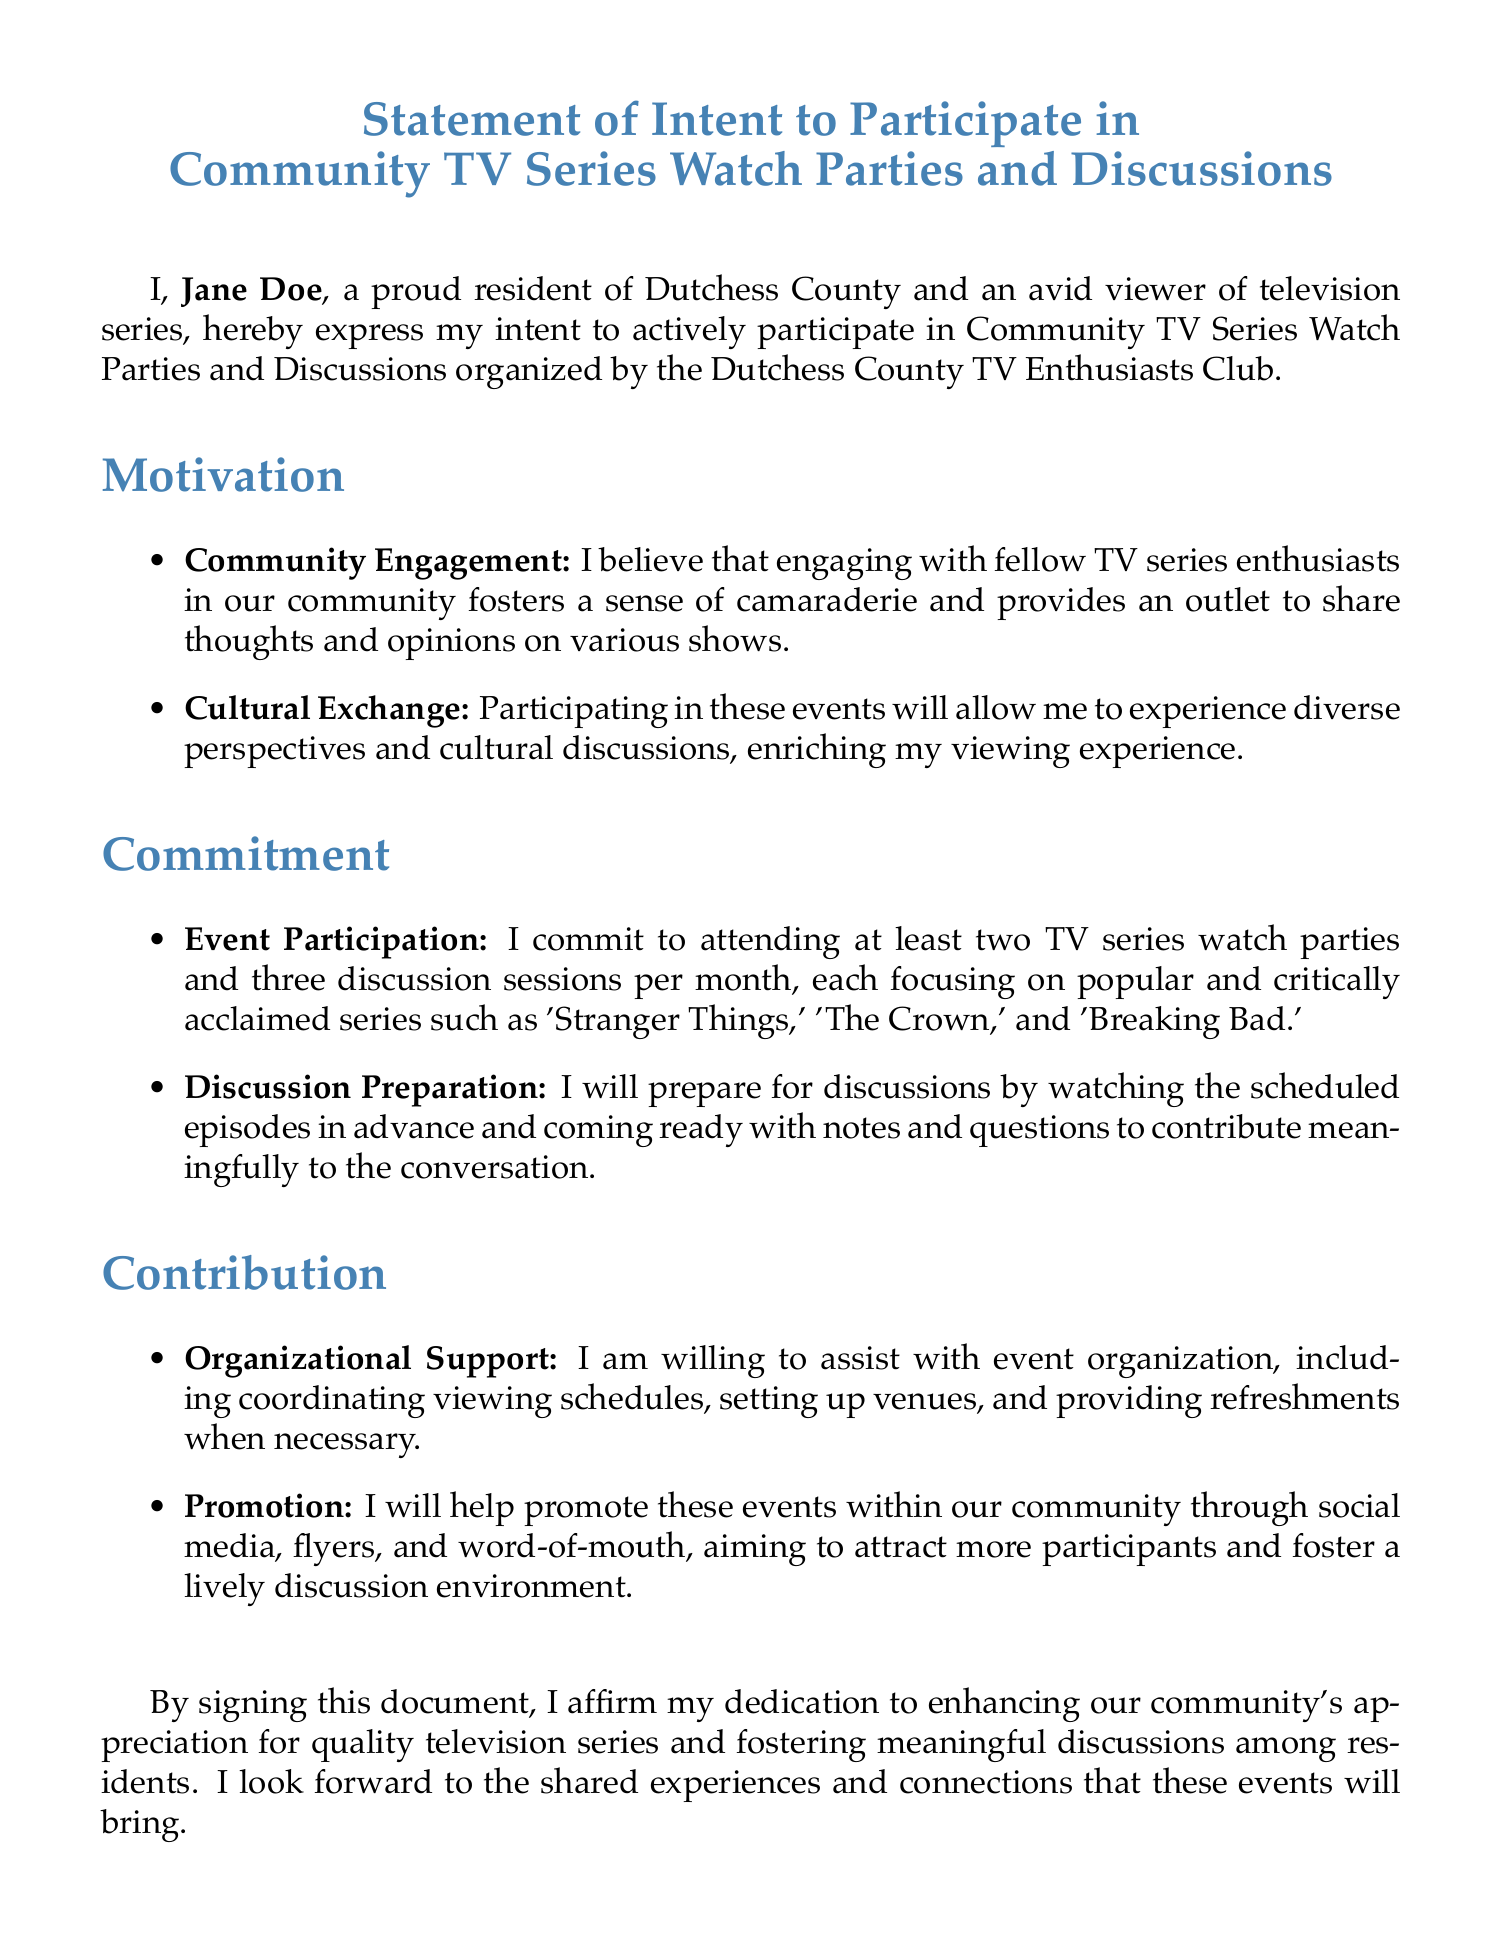What is the document titled? The title of the document is stated at the beginning, outlining the purpose of the declaration.
Answer: Statement of Intent to Participate in Community TV Series Watch Parties and Discussions Who is the signatory of the document? The document mentions the individual's name explicitly in the text.
Answer: Jane Doe What is the minimum number of watch parties the signatory commits to attend per month? The commitment section specifies the required attendance for the watch parties.
Answer: Two How many discussion sessions is the signatory committed to attending each month? The document details the required participation in discussion sessions.
Answer: Three What show is mentioned in the list of series to be discussed? The document provides examples of popular series that will be part of the discussions.
Answer: Stranger Things What type of support is the signatory willing to provide for event organization? The contribution section outlines the types of support offered by the signatory.
Answer: Organizational Support What is the date of the document? The document displays the date at the end, reflecting when it was created.
Answer: October 21, 2023 What color is used for the main text in the title? The title formatting specifies the color used for the text in the document's title.
Answer: tvblue 